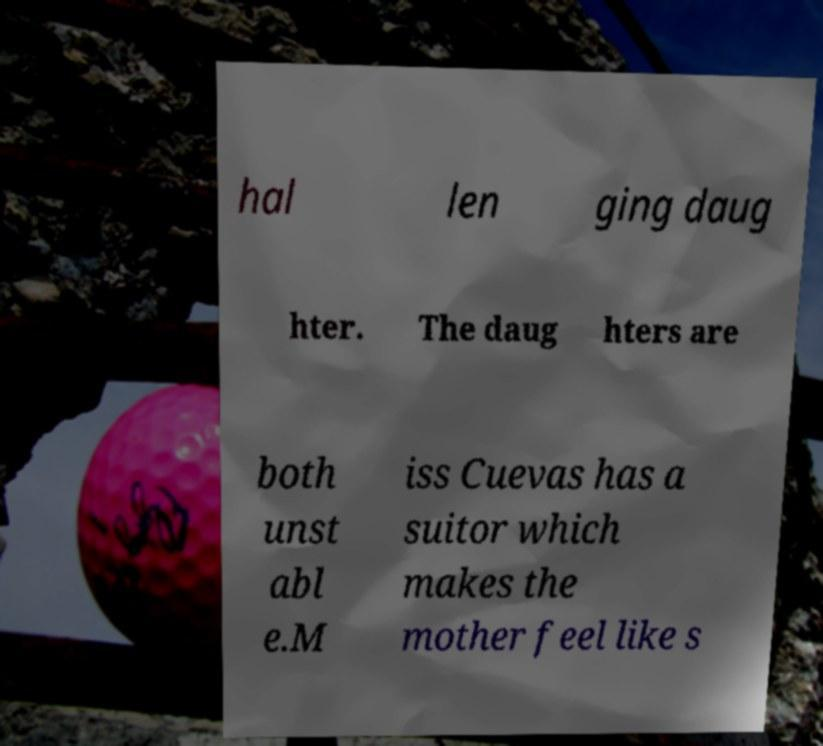Can you accurately transcribe the text from the provided image for me? hal len ging daug hter. The daug hters are both unst abl e.M iss Cuevas has a suitor which makes the mother feel like s 